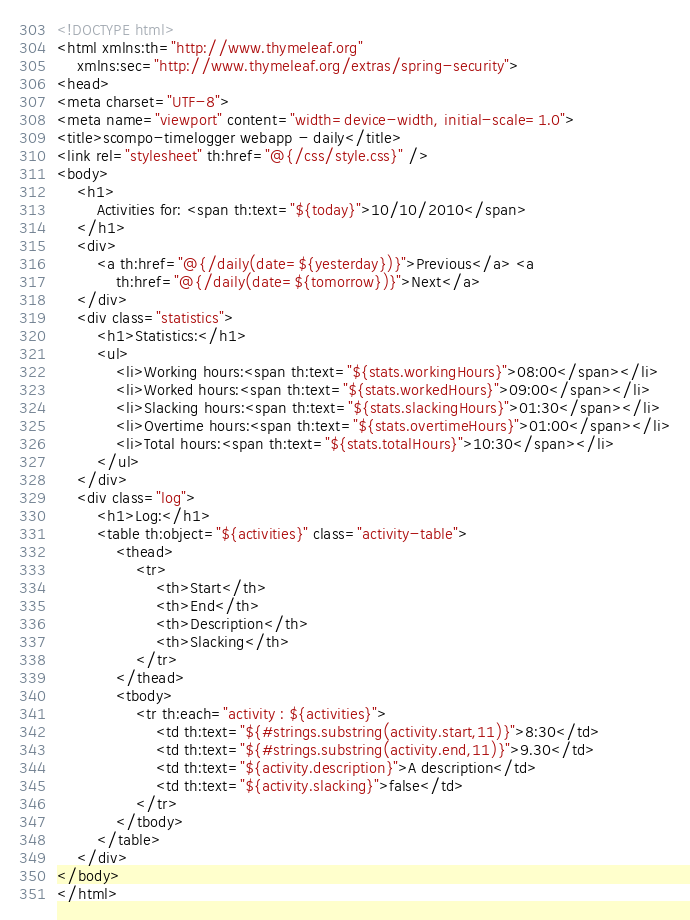Convert code to text. <code><loc_0><loc_0><loc_500><loc_500><_HTML_><!DOCTYPE html>
<html xmlns:th="http://www.thymeleaf.org"
	xmlns:sec="http://www.thymeleaf.org/extras/spring-security">
<head>
<meta charset="UTF-8">
<meta name="viewport" content="width=device-width, initial-scale=1.0">
<title>scompo-timelogger webapp - daily</title>
<link rel="stylesheet" th:href="@{/css/style.css}" />
<body>
	<h1>
		Activities for: <span th:text="${today}">10/10/2010</span>
	</h1>
	<div>
		<a th:href="@{/daily(date=${yesterday})}">Previous</a> <a
			th:href="@{/daily(date=${tomorrow})}">Next</a>
	</div>
	<div class="statistics">
		<h1>Statistics:</h1>
		<ul>
			<li>Working hours:<span th:text="${stats.workingHours}">08:00</span></li>
			<li>Worked hours:<span th:text="${stats.workedHours}">09:00</span></li>
			<li>Slacking hours:<span th:text="${stats.slackingHours}">01:30</span></li>
			<li>Overtime hours:<span th:text="${stats.overtimeHours}">01:00</span></li>
			<li>Total hours:<span th:text="${stats.totalHours}">10:30</span></li>
		</ul>
	</div>
	<div class="log">
		<h1>Log:</h1>
		<table th:object="${activities}" class="activity-table">
			<thead>
				<tr>
					<th>Start</th>
					<th>End</th>
					<th>Description</th>
					<th>Slacking</th>
				</tr>
			</thead>
			<tbody>
				<tr th:each="activity : ${activities}">
					<td th:text="${#strings.substring(activity.start,11)}">8:30</td>
					<td th:text="${#strings.substring(activity.end,11)}">9.30</td>
					<td th:text="${activity.description}">A description</td>
					<td th:text="${activity.slacking}">false</td>
				</tr>
			</tbody>
		</table>
	</div>
</body>
</html></code> 